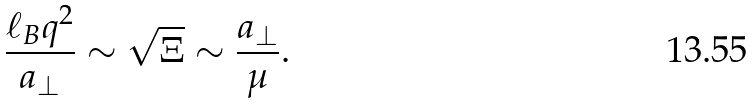<formula> <loc_0><loc_0><loc_500><loc_500>\frac { \ell _ { B } q ^ { 2 } } { a _ { \perp } } \sim \sqrt { \Xi } \sim \frac { a _ { \perp } } { \mu } .</formula> 